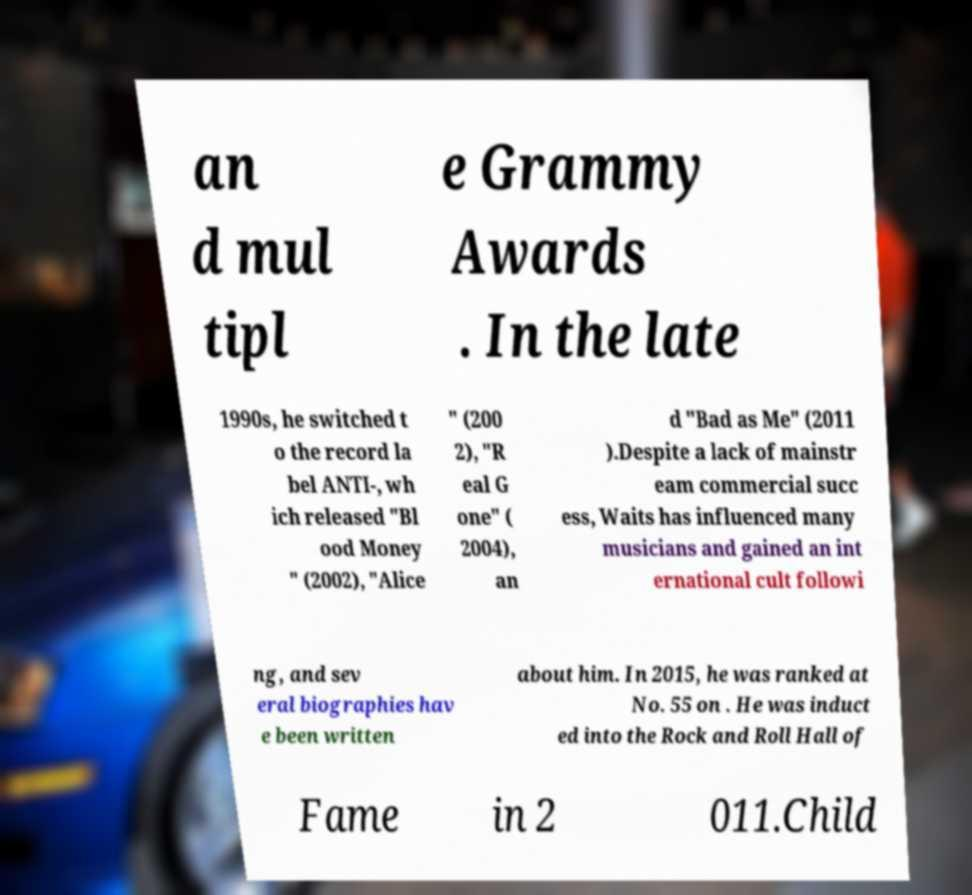For documentation purposes, I need the text within this image transcribed. Could you provide that? an d mul tipl e Grammy Awards . In the late 1990s, he switched t o the record la bel ANTI-, wh ich released "Bl ood Money " (2002), "Alice " (200 2), "R eal G one" ( 2004), an d "Bad as Me" (2011 ).Despite a lack of mainstr eam commercial succ ess, Waits has influenced many musicians and gained an int ernational cult followi ng, and sev eral biographies hav e been written about him. In 2015, he was ranked at No. 55 on . He was induct ed into the Rock and Roll Hall of Fame in 2 011.Child 